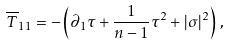<formula> <loc_0><loc_0><loc_500><loc_500>\overline { T } _ { 1 1 } = - \left ( \partial _ { 1 } \tau + \frac { 1 } { n - 1 } \tau ^ { 2 } + | \sigma | ^ { 2 } \right ) \, ,</formula> 